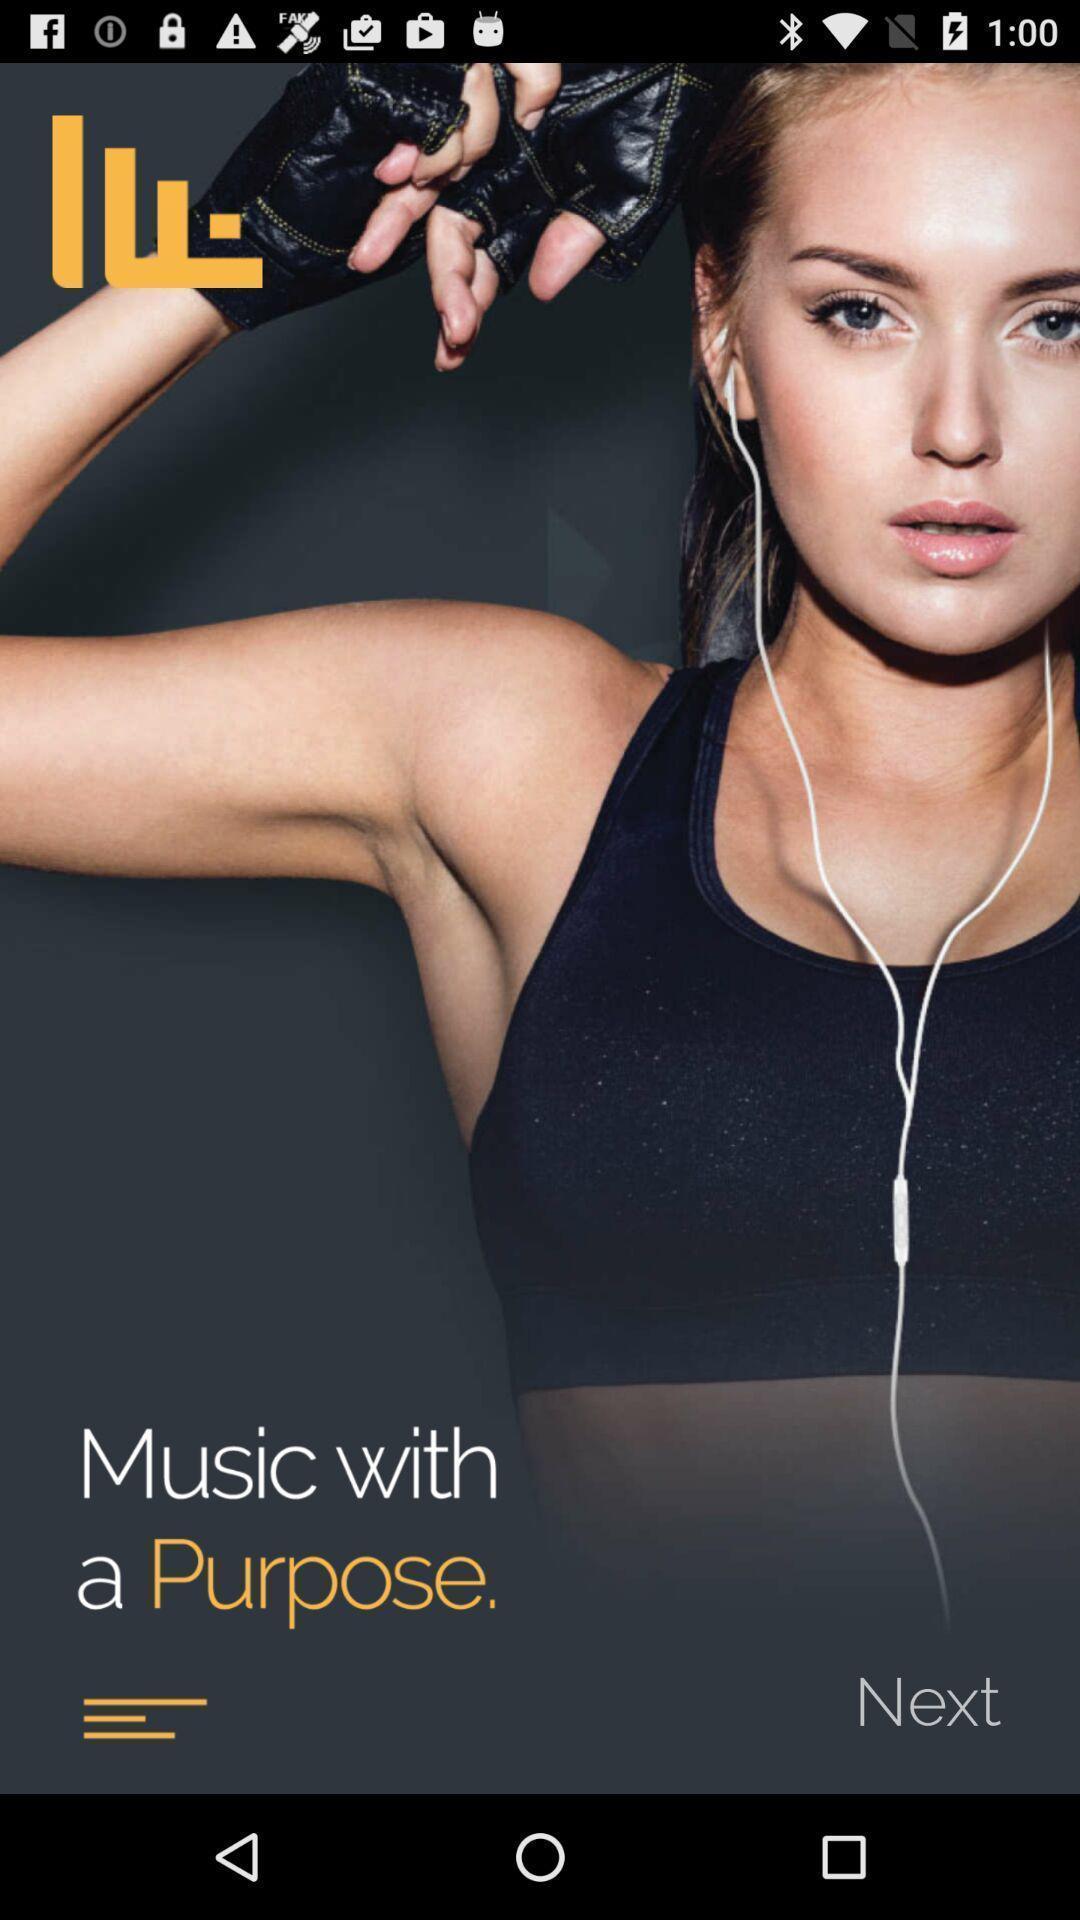Describe this image in words. Welcome page of a music player app. 